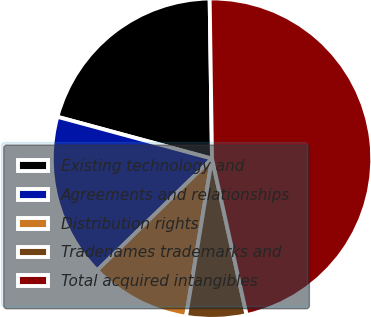Convert chart to OTSL. <chart><loc_0><loc_0><loc_500><loc_500><pie_chart><fcel>Existing technology and<fcel>Agreements and relationships<fcel>Distribution rights<fcel>Tradenames trademarks and<fcel>Total acquired intangibles<nl><fcel>20.56%<fcel>16.49%<fcel>10.13%<fcel>6.06%<fcel>46.77%<nl></chart> 